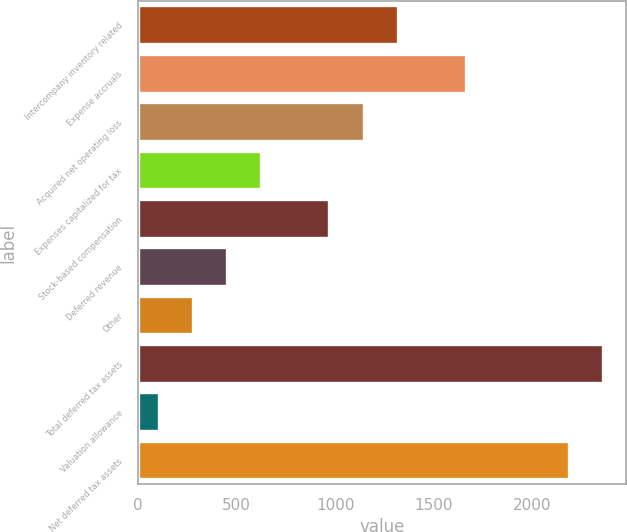Convert chart. <chart><loc_0><loc_0><loc_500><loc_500><bar_chart><fcel>Intercompany inventory related<fcel>Expense accruals<fcel>Acquired net operating loss<fcel>Expenses capitalized for tax<fcel>Stock-based compensation<fcel>Deferred revenue<fcel>Other<fcel>Total deferred tax assets<fcel>Valuation allowance<fcel>Net deferred tax assets<nl><fcel>1317.7<fcel>1663.9<fcel>1144.6<fcel>625.3<fcel>971.5<fcel>452.2<fcel>279.1<fcel>2356.3<fcel>106<fcel>2183.2<nl></chart> 